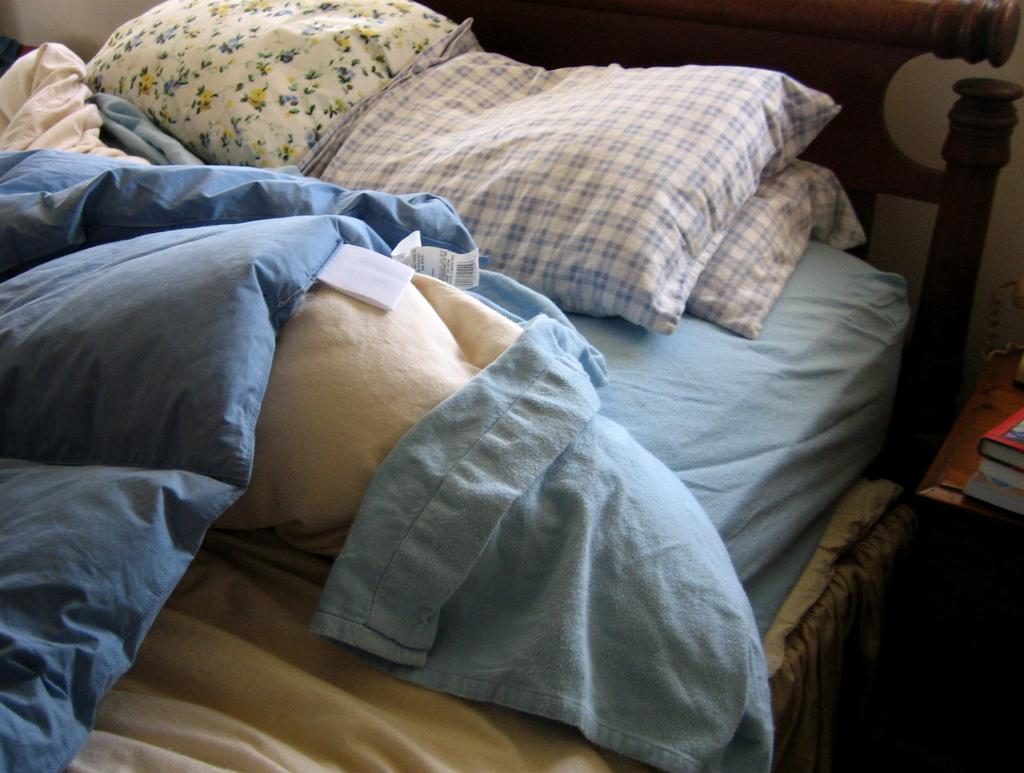What type of furniture is present in the image? There is a bed in the image. What accessories are on the bed? The bed has pillows on it. How are the blankets arranged on the bed? The bed has blankets in a messy arrangement. What type of spring can be seen on the bed in the image? There is no spring visible on the bed in the image. 